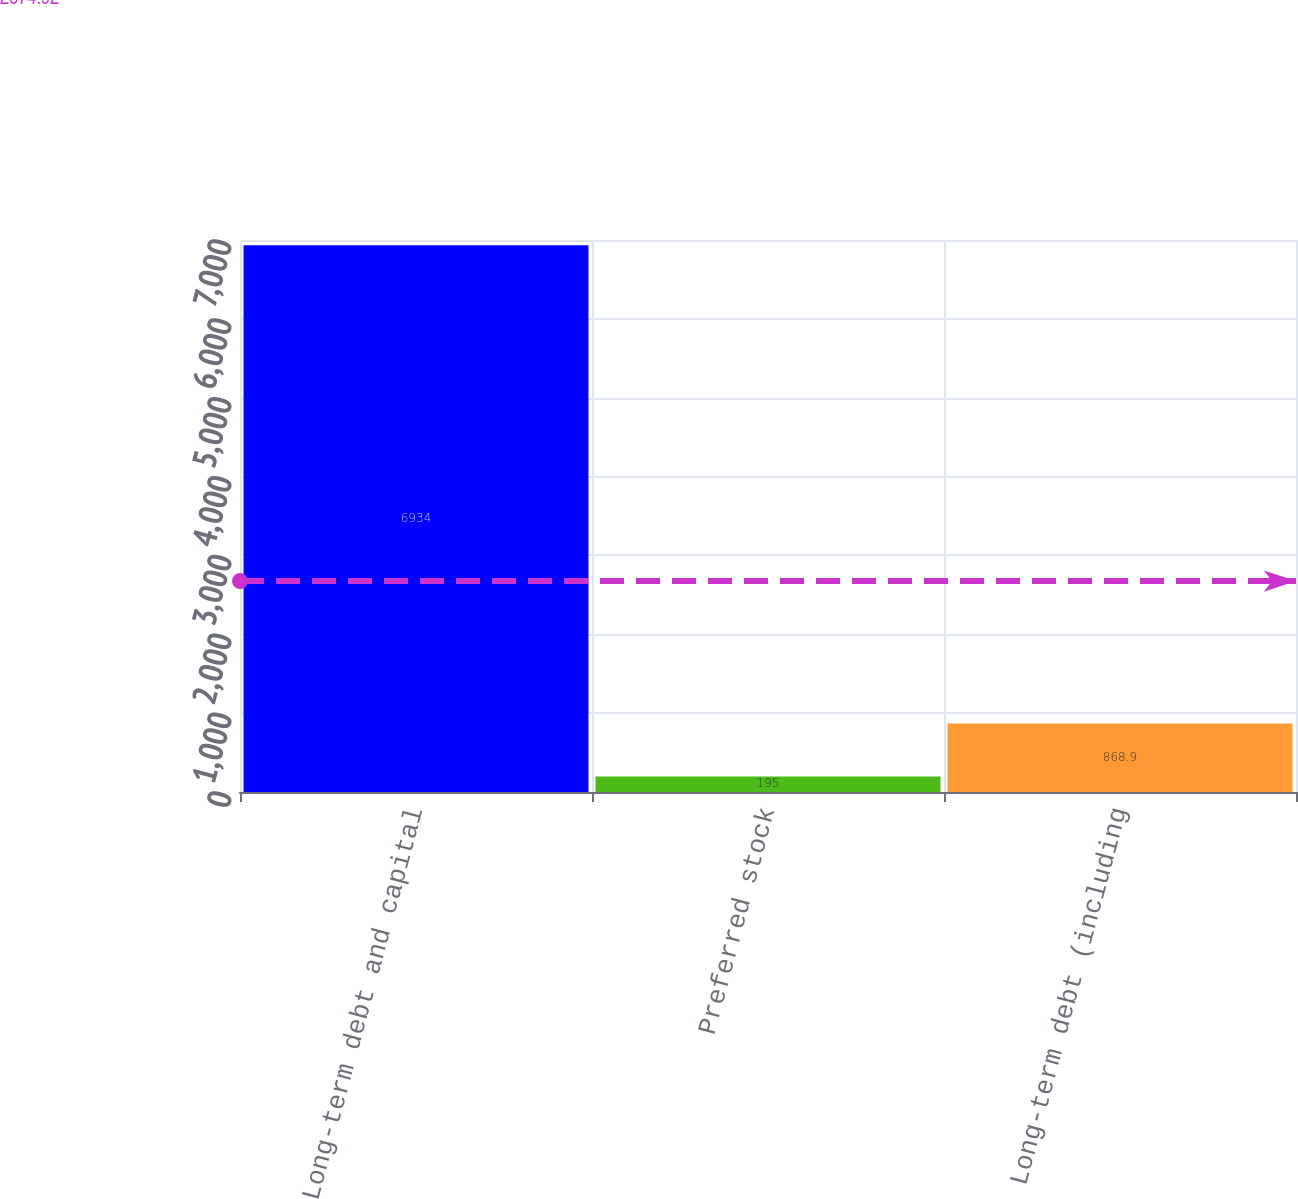Convert chart to OTSL. <chart><loc_0><loc_0><loc_500><loc_500><bar_chart><fcel>Long-term debt and capital<fcel>Preferred stock<fcel>Long-term debt (including<nl><fcel>6934<fcel>195<fcel>868.9<nl></chart> 